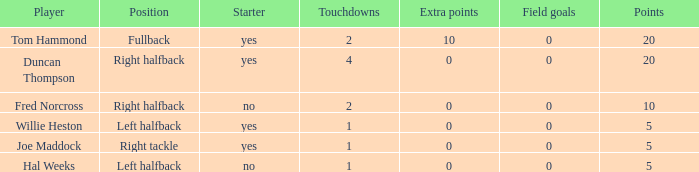What is the maximum number of field goals when there are multiple touchdowns and no extra points? 0.0. 